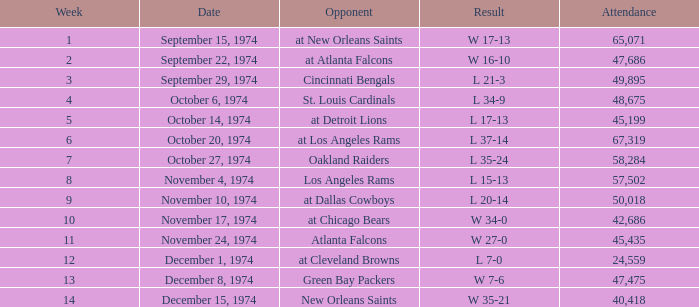What was the average attendance for games played at Atlanta Falcons? 47686.0. 